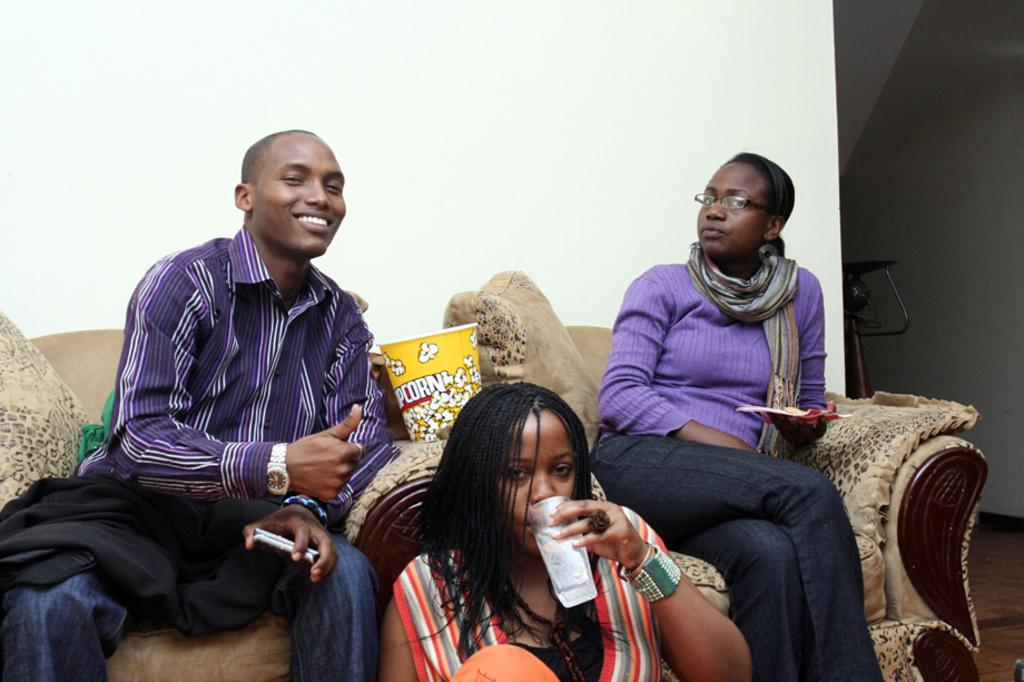What are the people in the image doing? The people in the image are sitting. What type of snack can be seen in the image? There is a popcorn box in the image. What type of locket is the person wearing in the image? There is no mention of a locket in the image, so it cannot be determined if someone is wearing one. What flavor of popcorn is in the box in the image? The flavor of the popcorn is not mentioned in the image, so it cannot be determined. 